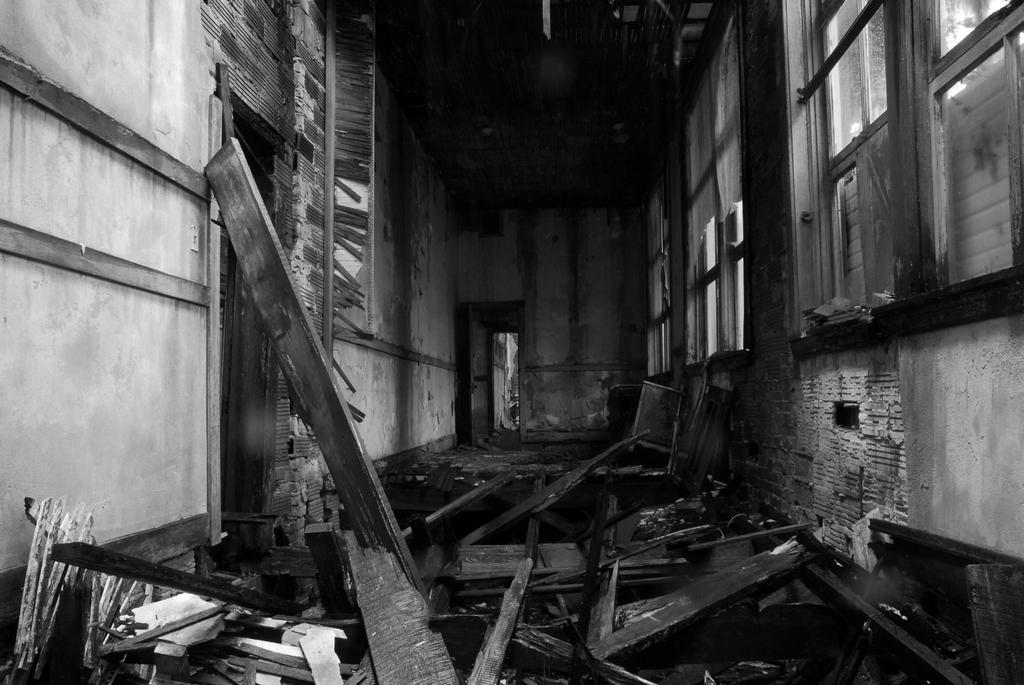What is the color scheme of the image? The image is black and white. What type of objects are visible in the image? There are wooden items in the image. How are the wooden items arranged in the image? The wooden items are stacked on top of each other. Where are the wooden items located in the image? The wooden items are on the floor. What type of location is depicted in the image? The scene takes place inside a house. What can be seen through the windows in the image? There are windows in the image, but the facts do not specify what can be seen through them. How many bushes are visible outside the windows in the image? There are no bushes visible outside the windows in the image, as the facts do not mention any bushes or outdoor elements. 